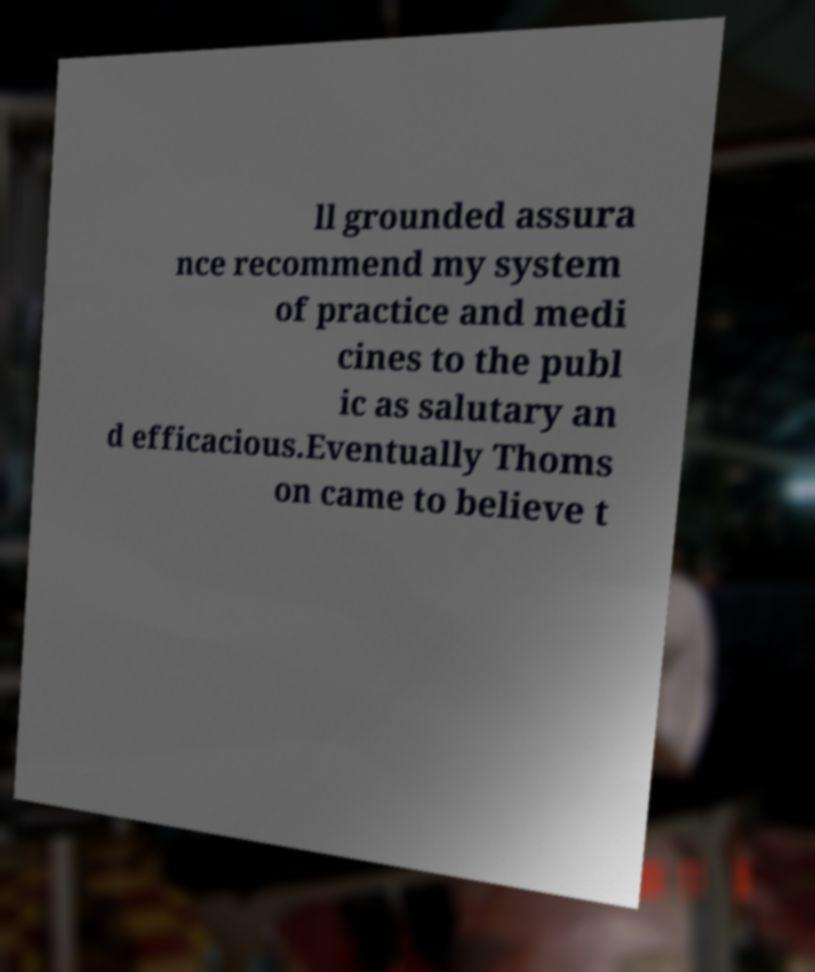Can you accurately transcribe the text from the provided image for me? ll grounded assura nce recommend my system of practice and medi cines to the publ ic as salutary an d efficacious.Eventually Thoms on came to believe t 